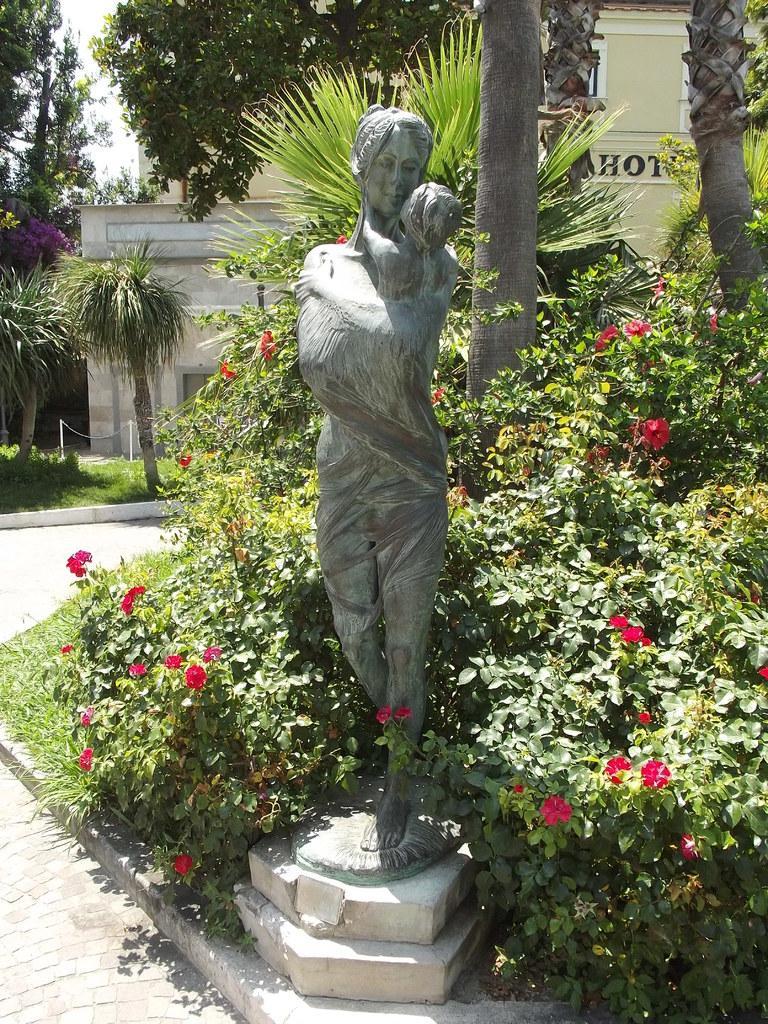Could you give a brief overview of what you see in this image? In this image we can see a statue and some flowers on plants. In the background, we can see a group of trees, grass, building with some text and the sky. 